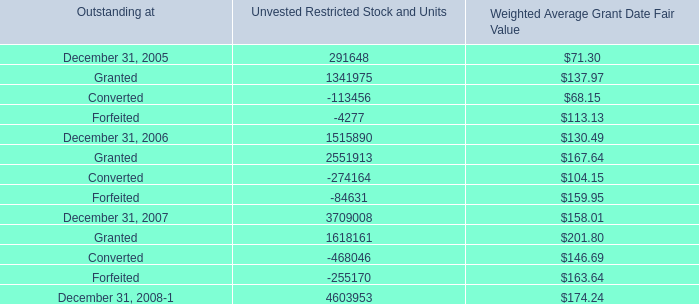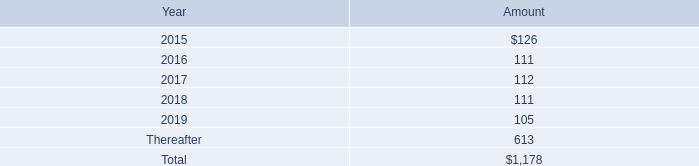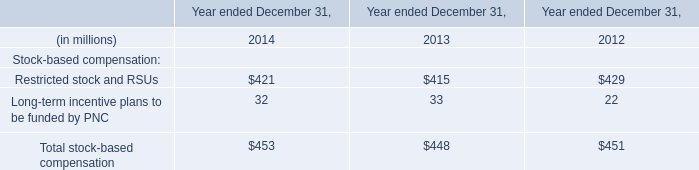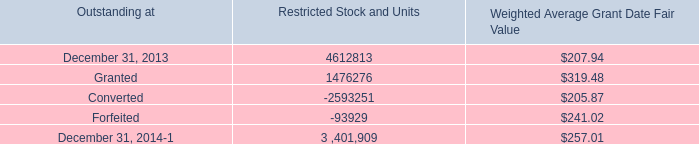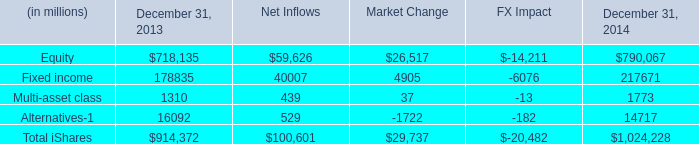what's the total amount of December 31, 2013 of Restricted Stock and Units, and Fixed income of FX Impact ? 
Computations: (4612813.0 + 6076.0)
Answer: 4618889.0. 